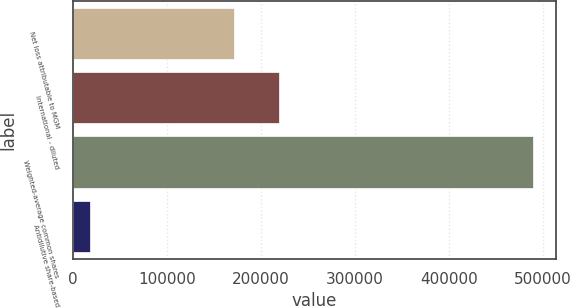Convert chart. <chart><loc_0><loc_0><loc_500><loc_500><bar_chart><fcel>Net loss attributable to MGM<fcel>International - diluted<fcel>Weighted-average common shares<fcel>Antidilutive share-based<nl><fcel>171734<fcel>218853<fcel>489661<fcel>18468<nl></chart> 